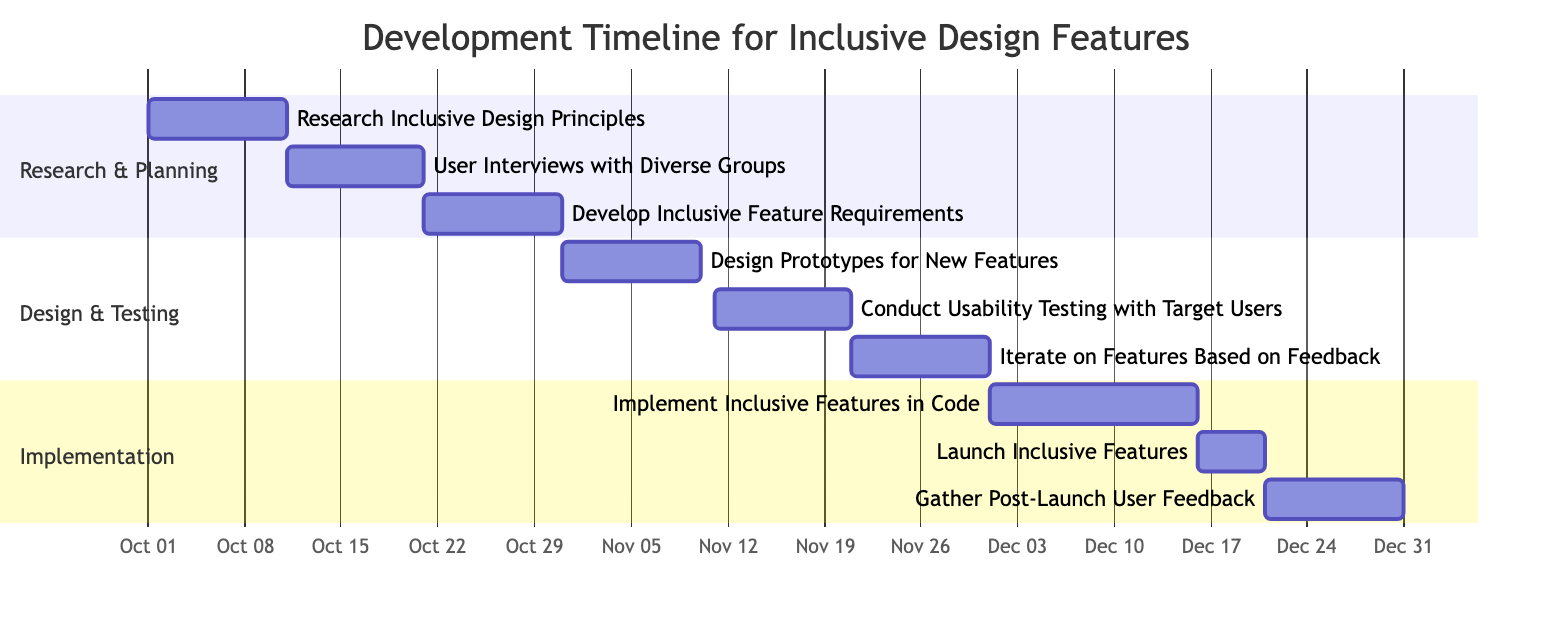What is the duration of the task "User Interviews with Diverse Groups"? The task "User Interviews with Diverse Groups" is listed in the Gantt chart with a duration of 10 days, starting from October 11, 2023, to October 20, 2023.
Answer: 10 days Which task occurs after "Design Prototypes for New Features"? After the task "Design Prototypes for New Features", the next task is "Conduct Usability Testing with Target Users", which starts on November 11, 2023.
Answer: Conduct Usability Testing with Target Users How many tasks are in the "Implementation" section of the Gantt chart? The "Implementation" section includes three tasks: "Implement Inclusive Features in Code", "Launch Inclusive Features", and "Gather Post-Launch User Feedback". Counting these gives a total of 3 tasks.
Answer: 3 What is the end date of the task "Gather Post-Launch User Feedback"? The task "Gather Post-Launch User Feedback" ends on December 31, 2023, as indicated in the provided data.
Answer: December 31, 2023 Which task has the longest duration in the Gantt chart? The task with the longest duration in the Gantt chart is "Implement Inclusive Features in Code," which has a duration of 15 days.
Answer: 15 days What is the relationship between "Iterate on Features Based on Feedback" and "Conduct Usability Testing with Target Users"? "Iterate on Features Based on Feedback" follows "Conduct Usability Testing with Target Users" sequentially, indicating that it starts after receiving user feedback from the usability testing.
Answer: Sequential relationship When does the "Research & Planning" section start and end? The "Research & Planning" section starts on October 1, 2023, with the "Research Inclusive Design Principles" task and ends on October 30, 2023, with the "Develop Inclusive Feature Requirements" task.
Answer: October 1 - October 30, 2023 How many days are there between the end of "Launch Inclusive Features" and the start of "Gather Post-Launch User Feedback"? "Launch Inclusive Features" ends on December 20, 2023, and "Gather Post-Launch User Feedback" starts on December 21, 2023, indicating there is one day in between.
Answer: 1 day What is the overall timeline span of the project from start to finish? The overall project starts on October 1, 2023, and finishes on December 31, 2023, making the total timeline span approximately three months.
Answer: Approximately three months 